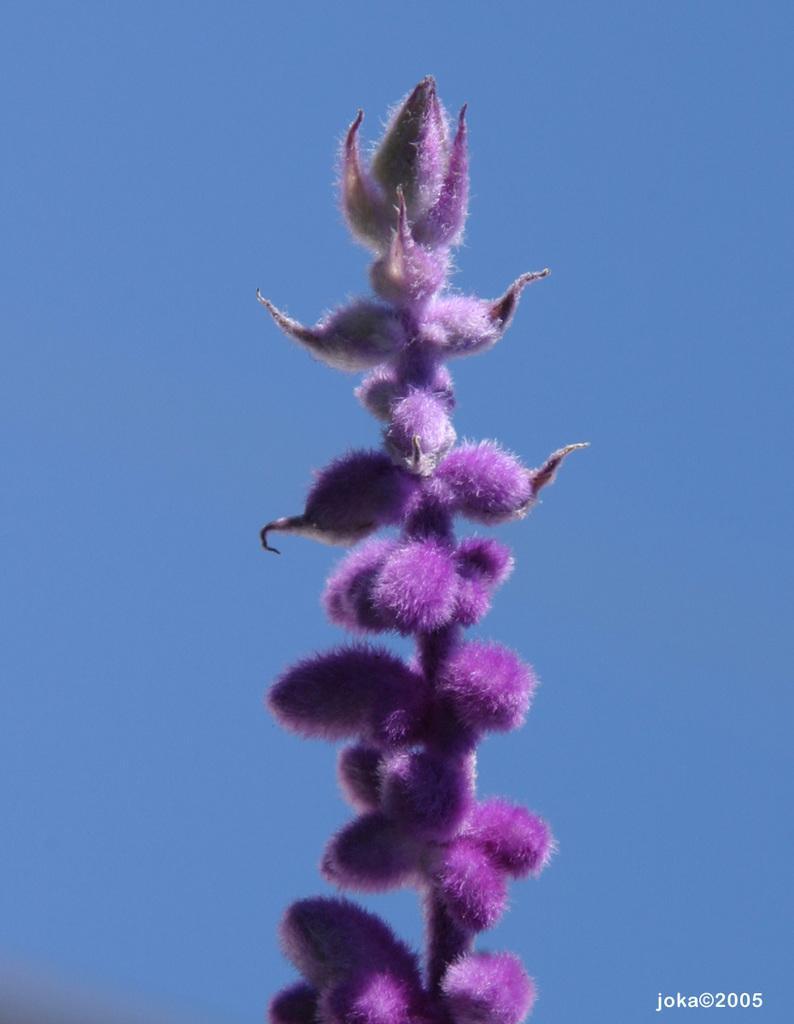In one or two sentences, can you explain what this image depicts? In this picture there is a violet color flower and there is something written in the right bottom corner and the sky is in blue color. 